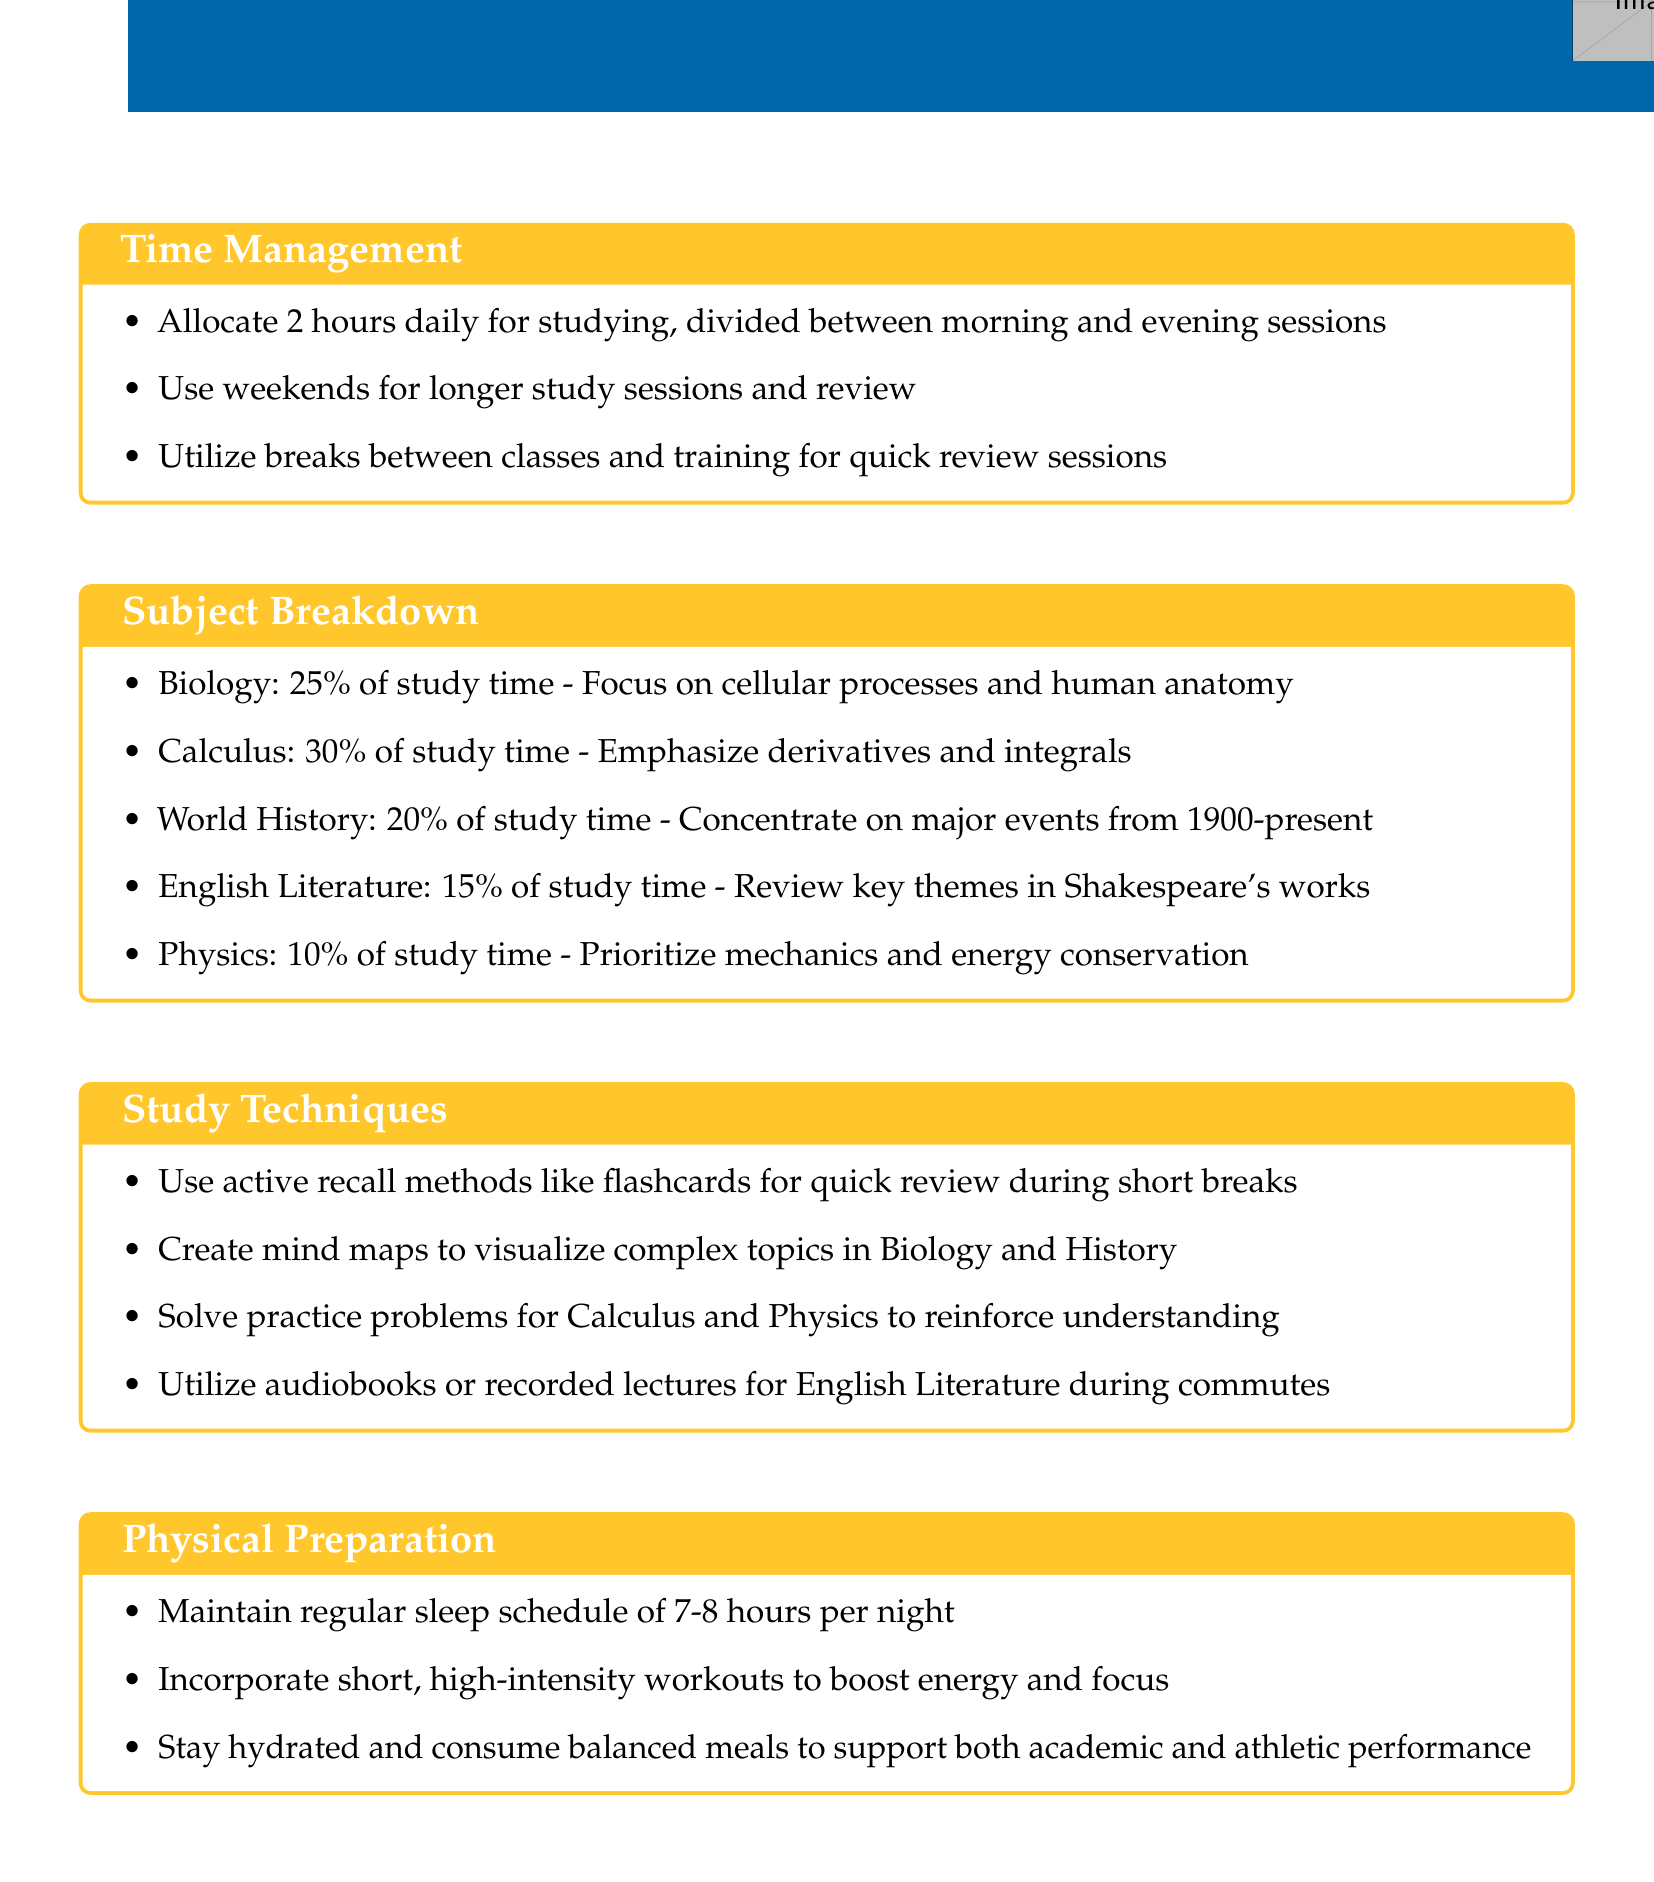What is the total study time allocated for Biology? The document states that 25% of the study time is allocated for Biology.
Answer: 25% How many hours of study are allocated daily? The document specifies that 2 hours daily are allocated for studying.
Answer: 2 hours Which subject has the highest percentage of study time? The subject breakdown shows that Calculus has the highest percentage at 30% of study time.
Answer: Calculus What technique is suggested for quick review during short breaks? The document recommends using active recall methods like flashcards for quick review.
Answer: Flashcards What percentage of study time is dedicated to English Literature? The breakdown indicates that 15% of study time is dedicated to English Literature.
Answer: 15% Which physical preparation aspect emphasizes sleep? The document states that maintaining a regular sleep schedule of 7-8 hours is important for physical preparation.
Answer: Sleep schedule What is recommended for creating visual aids? The document suggests creating mind maps to visualize complex topics in Biology and History.
Answer: Mind maps What percentage of study time is allocated for Physics? The document indicates that 10% of study time is allocated for Physics.
Answer: 10% How should weekends be utilized according to the study plan? The study plan advises using weekends for longer study sessions and review.
Answer: Longer study sessions 